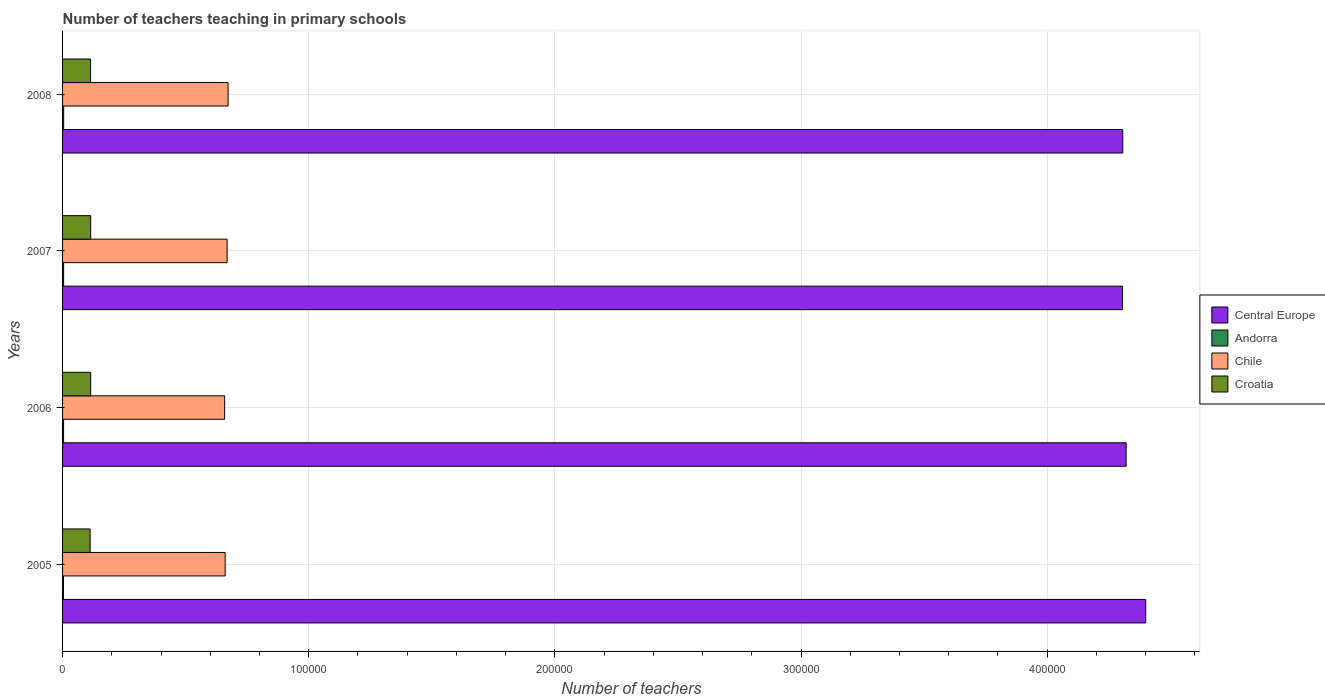How many different coloured bars are there?
Your answer should be very brief. 4. How many groups of bars are there?
Offer a terse response. 4. Are the number of bars per tick equal to the number of legend labels?
Offer a very short reply. Yes. How many bars are there on the 2nd tick from the bottom?
Offer a very short reply. 4. What is the label of the 2nd group of bars from the top?
Provide a succinct answer. 2007. In how many cases, is the number of bars for a given year not equal to the number of legend labels?
Offer a terse response. 0. What is the number of teachers teaching in primary schools in Croatia in 2007?
Offer a very short reply. 1.14e+04. Across all years, what is the maximum number of teachers teaching in primary schools in Croatia?
Your response must be concise. 1.14e+04. Across all years, what is the minimum number of teachers teaching in primary schools in Central Europe?
Your response must be concise. 4.31e+05. In which year was the number of teachers teaching in primary schools in Andorra maximum?
Provide a short and direct response. 2008. In which year was the number of teachers teaching in primary schools in Andorra minimum?
Provide a succinct answer. 2005. What is the total number of teachers teaching in primary schools in Croatia in the graph?
Provide a short and direct response. 4.54e+04. What is the difference between the number of teachers teaching in primary schools in Andorra in 2005 and that in 2006?
Provide a short and direct response. -57. What is the difference between the number of teachers teaching in primary schools in Croatia in 2005 and the number of teachers teaching in primary schools in Chile in 2007?
Make the answer very short. -5.57e+04. What is the average number of teachers teaching in primary schools in Croatia per year?
Provide a short and direct response. 1.14e+04. In the year 2008, what is the difference between the number of teachers teaching in primary schools in Central Europe and number of teachers teaching in primary schools in Croatia?
Your answer should be very brief. 4.19e+05. In how many years, is the number of teachers teaching in primary schools in Chile greater than 380000 ?
Give a very brief answer. 0. What is the ratio of the number of teachers teaching in primary schools in Chile in 2007 to that in 2008?
Offer a terse response. 0.99. Is the number of teachers teaching in primary schools in Chile in 2007 less than that in 2008?
Keep it short and to the point. Yes. What is the difference between the highest and the second highest number of teachers teaching in primary schools in Croatia?
Your answer should be compact. 8. What is the difference between the highest and the lowest number of teachers teaching in primary schools in Central Europe?
Give a very brief answer. 9410.81. Is the sum of the number of teachers teaching in primary schools in Croatia in 2005 and 2006 greater than the maximum number of teachers teaching in primary schools in Central Europe across all years?
Give a very brief answer. No. What does the 4th bar from the top in 2005 represents?
Provide a succinct answer. Central Europe. What does the 1st bar from the bottom in 2007 represents?
Offer a terse response. Central Europe. Is it the case that in every year, the sum of the number of teachers teaching in primary schools in Croatia and number of teachers teaching in primary schools in Andorra is greater than the number of teachers teaching in primary schools in Central Europe?
Your response must be concise. No. How many years are there in the graph?
Provide a succinct answer. 4. What is the difference between two consecutive major ticks on the X-axis?
Provide a short and direct response. 1.00e+05. Does the graph contain any zero values?
Your answer should be very brief. No. How are the legend labels stacked?
Keep it short and to the point. Vertical. What is the title of the graph?
Offer a very short reply. Number of teachers teaching in primary schools. Does "Cayman Islands" appear as one of the legend labels in the graph?
Your answer should be very brief. No. What is the label or title of the X-axis?
Offer a terse response. Number of teachers. What is the label or title of the Y-axis?
Your answer should be very brief. Years. What is the Number of teachers in Central Europe in 2005?
Your answer should be compact. 4.40e+05. What is the Number of teachers in Andorra in 2005?
Your answer should be very brief. 356. What is the Number of teachers of Chile in 2005?
Make the answer very short. 6.61e+04. What is the Number of teachers of Croatia in 2005?
Provide a short and direct response. 1.12e+04. What is the Number of teachers of Central Europe in 2006?
Your answer should be very brief. 4.32e+05. What is the Number of teachers in Andorra in 2006?
Offer a terse response. 413. What is the Number of teachers of Chile in 2006?
Your answer should be compact. 6.59e+04. What is the Number of teachers of Croatia in 2006?
Your response must be concise. 1.14e+04. What is the Number of teachers in Central Europe in 2007?
Give a very brief answer. 4.31e+05. What is the Number of teachers of Andorra in 2007?
Make the answer very short. 432. What is the Number of teachers in Chile in 2007?
Give a very brief answer. 6.69e+04. What is the Number of teachers of Croatia in 2007?
Keep it short and to the point. 1.14e+04. What is the Number of teachers in Central Europe in 2008?
Your answer should be very brief. 4.31e+05. What is the Number of teachers in Andorra in 2008?
Provide a succinct answer. 448. What is the Number of teachers in Chile in 2008?
Your answer should be compact. 6.72e+04. What is the Number of teachers in Croatia in 2008?
Give a very brief answer. 1.14e+04. Across all years, what is the maximum Number of teachers of Central Europe?
Ensure brevity in your answer.  4.40e+05. Across all years, what is the maximum Number of teachers of Andorra?
Your answer should be very brief. 448. Across all years, what is the maximum Number of teachers of Chile?
Your answer should be very brief. 6.72e+04. Across all years, what is the maximum Number of teachers in Croatia?
Make the answer very short. 1.14e+04. Across all years, what is the minimum Number of teachers of Central Europe?
Keep it short and to the point. 4.31e+05. Across all years, what is the minimum Number of teachers of Andorra?
Offer a very short reply. 356. Across all years, what is the minimum Number of teachers of Chile?
Offer a very short reply. 6.59e+04. Across all years, what is the minimum Number of teachers of Croatia?
Keep it short and to the point. 1.12e+04. What is the total Number of teachers in Central Europe in the graph?
Your answer should be very brief. 1.73e+06. What is the total Number of teachers in Andorra in the graph?
Provide a succinct answer. 1649. What is the total Number of teachers in Chile in the graph?
Offer a very short reply. 2.66e+05. What is the total Number of teachers in Croatia in the graph?
Keep it short and to the point. 4.54e+04. What is the difference between the Number of teachers in Central Europe in 2005 and that in 2006?
Your answer should be compact. 7940.81. What is the difference between the Number of teachers in Andorra in 2005 and that in 2006?
Provide a succinct answer. -57. What is the difference between the Number of teachers in Chile in 2005 and that in 2006?
Provide a short and direct response. 208. What is the difference between the Number of teachers in Croatia in 2005 and that in 2006?
Give a very brief answer. -217. What is the difference between the Number of teachers of Central Europe in 2005 and that in 2007?
Provide a short and direct response. 9410.81. What is the difference between the Number of teachers in Andorra in 2005 and that in 2007?
Offer a very short reply. -76. What is the difference between the Number of teachers in Chile in 2005 and that in 2007?
Keep it short and to the point. -802. What is the difference between the Number of teachers in Croatia in 2005 and that in 2007?
Give a very brief answer. -225. What is the difference between the Number of teachers in Central Europe in 2005 and that in 2008?
Keep it short and to the point. 9306.81. What is the difference between the Number of teachers in Andorra in 2005 and that in 2008?
Make the answer very short. -92. What is the difference between the Number of teachers in Chile in 2005 and that in 2008?
Your response must be concise. -1180. What is the difference between the Number of teachers in Croatia in 2005 and that in 2008?
Keep it short and to the point. -175. What is the difference between the Number of teachers in Central Europe in 2006 and that in 2007?
Ensure brevity in your answer.  1470. What is the difference between the Number of teachers of Andorra in 2006 and that in 2007?
Offer a very short reply. -19. What is the difference between the Number of teachers in Chile in 2006 and that in 2007?
Provide a short and direct response. -1010. What is the difference between the Number of teachers in Croatia in 2006 and that in 2007?
Your response must be concise. -8. What is the difference between the Number of teachers of Central Europe in 2006 and that in 2008?
Offer a very short reply. 1366. What is the difference between the Number of teachers in Andorra in 2006 and that in 2008?
Ensure brevity in your answer.  -35. What is the difference between the Number of teachers in Chile in 2006 and that in 2008?
Give a very brief answer. -1388. What is the difference between the Number of teachers of Croatia in 2006 and that in 2008?
Offer a terse response. 42. What is the difference between the Number of teachers of Central Europe in 2007 and that in 2008?
Your response must be concise. -104. What is the difference between the Number of teachers of Andorra in 2007 and that in 2008?
Your answer should be compact. -16. What is the difference between the Number of teachers in Chile in 2007 and that in 2008?
Your answer should be compact. -378. What is the difference between the Number of teachers in Croatia in 2007 and that in 2008?
Your answer should be compact. 50. What is the difference between the Number of teachers of Central Europe in 2005 and the Number of teachers of Andorra in 2006?
Ensure brevity in your answer.  4.40e+05. What is the difference between the Number of teachers of Central Europe in 2005 and the Number of teachers of Chile in 2006?
Your response must be concise. 3.74e+05. What is the difference between the Number of teachers of Central Europe in 2005 and the Number of teachers of Croatia in 2006?
Ensure brevity in your answer.  4.29e+05. What is the difference between the Number of teachers of Andorra in 2005 and the Number of teachers of Chile in 2006?
Your answer should be compact. -6.55e+04. What is the difference between the Number of teachers in Andorra in 2005 and the Number of teachers in Croatia in 2006?
Make the answer very short. -1.11e+04. What is the difference between the Number of teachers of Chile in 2005 and the Number of teachers of Croatia in 2006?
Offer a terse response. 5.46e+04. What is the difference between the Number of teachers of Central Europe in 2005 and the Number of teachers of Andorra in 2007?
Your answer should be compact. 4.40e+05. What is the difference between the Number of teachers of Central Europe in 2005 and the Number of teachers of Chile in 2007?
Make the answer very short. 3.73e+05. What is the difference between the Number of teachers of Central Europe in 2005 and the Number of teachers of Croatia in 2007?
Your answer should be very brief. 4.29e+05. What is the difference between the Number of teachers in Andorra in 2005 and the Number of teachers in Chile in 2007?
Make the answer very short. -6.65e+04. What is the difference between the Number of teachers in Andorra in 2005 and the Number of teachers in Croatia in 2007?
Give a very brief answer. -1.11e+04. What is the difference between the Number of teachers of Chile in 2005 and the Number of teachers of Croatia in 2007?
Keep it short and to the point. 5.46e+04. What is the difference between the Number of teachers of Central Europe in 2005 and the Number of teachers of Andorra in 2008?
Make the answer very short. 4.40e+05. What is the difference between the Number of teachers in Central Europe in 2005 and the Number of teachers in Chile in 2008?
Provide a short and direct response. 3.73e+05. What is the difference between the Number of teachers in Central Europe in 2005 and the Number of teachers in Croatia in 2008?
Provide a short and direct response. 4.29e+05. What is the difference between the Number of teachers of Andorra in 2005 and the Number of teachers of Chile in 2008?
Your answer should be compact. -6.69e+04. What is the difference between the Number of teachers of Andorra in 2005 and the Number of teachers of Croatia in 2008?
Your answer should be compact. -1.10e+04. What is the difference between the Number of teachers of Chile in 2005 and the Number of teachers of Croatia in 2008?
Offer a very short reply. 5.47e+04. What is the difference between the Number of teachers in Central Europe in 2006 and the Number of teachers in Andorra in 2007?
Your answer should be compact. 4.32e+05. What is the difference between the Number of teachers of Central Europe in 2006 and the Number of teachers of Chile in 2007?
Give a very brief answer. 3.65e+05. What is the difference between the Number of teachers in Central Europe in 2006 and the Number of teachers in Croatia in 2007?
Ensure brevity in your answer.  4.21e+05. What is the difference between the Number of teachers in Andorra in 2006 and the Number of teachers in Chile in 2007?
Provide a short and direct response. -6.64e+04. What is the difference between the Number of teachers in Andorra in 2006 and the Number of teachers in Croatia in 2007?
Ensure brevity in your answer.  -1.10e+04. What is the difference between the Number of teachers of Chile in 2006 and the Number of teachers of Croatia in 2007?
Provide a succinct answer. 5.44e+04. What is the difference between the Number of teachers of Central Europe in 2006 and the Number of teachers of Andorra in 2008?
Ensure brevity in your answer.  4.32e+05. What is the difference between the Number of teachers of Central Europe in 2006 and the Number of teachers of Chile in 2008?
Make the answer very short. 3.65e+05. What is the difference between the Number of teachers in Central Europe in 2006 and the Number of teachers in Croatia in 2008?
Your answer should be very brief. 4.21e+05. What is the difference between the Number of teachers in Andorra in 2006 and the Number of teachers in Chile in 2008?
Provide a succinct answer. -6.68e+04. What is the difference between the Number of teachers of Andorra in 2006 and the Number of teachers of Croatia in 2008?
Keep it short and to the point. -1.10e+04. What is the difference between the Number of teachers of Chile in 2006 and the Number of teachers of Croatia in 2008?
Your response must be concise. 5.45e+04. What is the difference between the Number of teachers in Central Europe in 2007 and the Number of teachers in Andorra in 2008?
Offer a very short reply. 4.30e+05. What is the difference between the Number of teachers of Central Europe in 2007 and the Number of teachers of Chile in 2008?
Your answer should be very brief. 3.63e+05. What is the difference between the Number of teachers in Central Europe in 2007 and the Number of teachers in Croatia in 2008?
Your answer should be compact. 4.19e+05. What is the difference between the Number of teachers of Andorra in 2007 and the Number of teachers of Chile in 2008?
Provide a succinct answer. -6.68e+04. What is the difference between the Number of teachers in Andorra in 2007 and the Number of teachers in Croatia in 2008?
Keep it short and to the point. -1.09e+04. What is the difference between the Number of teachers of Chile in 2007 and the Number of teachers of Croatia in 2008?
Make the answer very short. 5.55e+04. What is the average Number of teachers in Central Europe per year?
Provide a succinct answer. 4.33e+05. What is the average Number of teachers of Andorra per year?
Ensure brevity in your answer.  412.25. What is the average Number of teachers of Chile per year?
Keep it short and to the point. 6.65e+04. What is the average Number of teachers in Croatia per year?
Make the answer very short. 1.14e+04. In the year 2005, what is the difference between the Number of teachers of Central Europe and Number of teachers of Andorra?
Give a very brief answer. 4.40e+05. In the year 2005, what is the difference between the Number of teachers of Central Europe and Number of teachers of Chile?
Your response must be concise. 3.74e+05. In the year 2005, what is the difference between the Number of teachers in Central Europe and Number of teachers in Croatia?
Your answer should be compact. 4.29e+05. In the year 2005, what is the difference between the Number of teachers in Andorra and Number of teachers in Chile?
Offer a terse response. -6.57e+04. In the year 2005, what is the difference between the Number of teachers of Andorra and Number of teachers of Croatia?
Offer a very short reply. -1.08e+04. In the year 2005, what is the difference between the Number of teachers of Chile and Number of teachers of Croatia?
Provide a succinct answer. 5.49e+04. In the year 2006, what is the difference between the Number of teachers of Central Europe and Number of teachers of Andorra?
Offer a terse response. 4.32e+05. In the year 2006, what is the difference between the Number of teachers in Central Europe and Number of teachers in Chile?
Ensure brevity in your answer.  3.66e+05. In the year 2006, what is the difference between the Number of teachers in Central Europe and Number of teachers in Croatia?
Your answer should be compact. 4.21e+05. In the year 2006, what is the difference between the Number of teachers in Andorra and Number of teachers in Chile?
Your answer should be compact. -6.54e+04. In the year 2006, what is the difference between the Number of teachers of Andorra and Number of teachers of Croatia?
Keep it short and to the point. -1.10e+04. In the year 2006, what is the difference between the Number of teachers in Chile and Number of teachers in Croatia?
Ensure brevity in your answer.  5.44e+04. In the year 2007, what is the difference between the Number of teachers in Central Europe and Number of teachers in Andorra?
Ensure brevity in your answer.  4.30e+05. In the year 2007, what is the difference between the Number of teachers of Central Europe and Number of teachers of Chile?
Keep it short and to the point. 3.64e+05. In the year 2007, what is the difference between the Number of teachers of Central Europe and Number of teachers of Croatia?
Ensure brevity in your answer.  4.19e+05. In the year 2007, what is the difference between the Number of teachers in Andorra and Number of teachers in Chile?
Your answer should be very brief. -6.64e+04. In the year 2007, what is the difference between the Number of teachers of Andorra and Number of teachers of Croatia?
Give a very brief answer. -1.10e+04. In the year 2007, what is the difference between the Number of teachers in Chile and Number of teachers in Croatia?
Provide a short and direct response. 5.54e+04. In the year 2008, what is the difference between the Number of teachers of Central Europe and Number of teachers of Andorra?
Make the answer very short. 4.30e+05. In the year 2008, what is the difference between the Number of teachers of Central Europe and Number of teachers of Chile?
Your response must be concise. 3.63e+05. In the year 2008, what is the difference between the Number of teachers of Central Europe and Number of teachers of Croatia?
Keep it short and to the point. 4.19e+05. In the year 2008, what is the difference between the Number of teachers of Andorra and Number of teachers of Chile?
Ensure brevity in your answer.  -6.68e+04. In the year 2008, what is the difference between the Number of teachers of Andorra and Number of teachers of Croatia?
Your answer should be very brief. -1.09e+04. In the year 2008, what is the difference between the Number of teachers in Chile and Number of teachers in Croatia?
Your response must be concise. 5.59e+04. What is the ratio of the Number of teachers in Central Europe in 2005 to that in 2006?
Ensure brevity in your answer.  1.02. What is the ratio of the Number of teachers in Andorra in 2005 to that in 2006?
Provide a succinct answer. 0.86. What is the ratio of the Number of teachers in Central Europe in 2005 to that in 2007?
Ensure brevity in your answer.  1.02. What is the ratio of the Number of teachers in Andorra in 2005 to that in 2007?
Offer a terse response. 0.82. What is the ratio of the Number of teachers of Chile in 2005 to that in 2007?
Your answer should be compact. 0.99. What is the ratio of the Number of teachers of Croatia in 2005 to that in 2007?
Keep it short and to the point. 0.98. What is the ratio of the Number of teachers of Central Europe in 2005 to that in 2008?
Provide a short and direct response. 1.02. What is the ratio of the Number of teachers in Andorra in 2005 to that in 2008?
Make the answer very short. 0.79. What is the ratio of the Number of teachers in Chile in 2005 to that in 2008?
Offer a terse response. 0.98. What is the ratio of the Number of teachers of Croatia in 2005 to that in 2008?
Your answer should be very brief. 0.98. What is the ratio of the Number of teachers in Andorra in 2006 to that in 2007?
Provide a succinct answer. 0.96. What is the ratio of the Number of teachers of Chile in 2006 to that in 2007?
Make the answer very short. 0.98. What is the ratio of the Number of teachers in Andorra in 2006 to that in 2008?
Your answer should be very brief. 0.92. What is the ratio of the Number of teachers in Chile in 2006 to that in 2008?
Provide a short and direct response. 0.98. What is the ratio of the Number of teachers in Croatia in 2006 to that in 2008?
Your answer should be compact. 1. What is the ratio of the Number of teachers in Central Europe in 2007 to that in 2008?
Your answer should be very brief. 1. What is the ratio of the Number of teachers of Andorra in 2007 to that in 2008?
Your answer should be very brief. 0.96. What is the ratio of the Number of teachers in Chile in 2007 to that in 2008?
Provide a short and direct response. 0.99. What is the ratio of the Number of teachers of Croatia in 2007 to that in 2008?
Your answer should be compact. 1. What is the difference between the highest and the second highest Number of teachers in Central Europe?
Your response must be concise. 7940.81. What is the difference between the highest and the second highest Number of teachers in Andorra?
Ensure brevity in your answer.  16. What is the difference between the highest and the second highest Number of teachers in Chile?
Keep it short and to the point. 378. What is the difference between the highest and the second highest Number of teachers of Croatia?
Your response must be concise. 8. What is the difference between the highest and the lowest Number of teachers of Central Europe?
Provide a short and direct response. 9410.81. What is the difference between the highest and the lowest Number of teachers in Andorra?
Give a very brief answer. 92. What is the difference between the highest and the lowest Number of teachers of Chile?
Your answer should be very brief. 1388. What is the difference between the highest and the lowest Number of teachers in Croatia?
Offer a terse response. 225. 